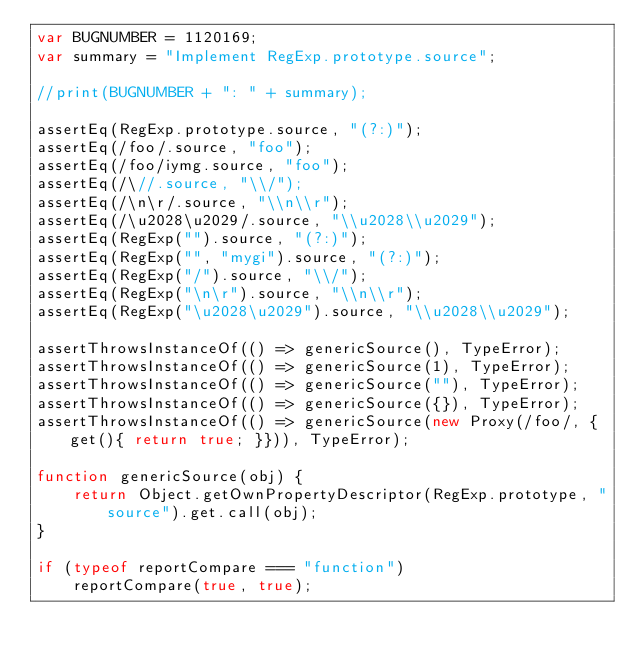<code> <loc_0><loc_0><loc_500><loc_500><_JavaScript_>var BUGNUMBER = 1120169;
var summary = "Implement RegExp.prototype.source";

//print(BUGNUMBER + ": " + summary);

assertEq(RegExp.prototype.source, "(?:)");
assertEq(/foo/.source, "foo");
assertEq(/foo/iymg.source, "foo");
assertEq(/\//.source, "\\/");
assertEq(/\n\r/.source, "\\n\\r");
assertEq(/\u2028\u2029/.source, "\\u2028\\u2029");
assertEq(RegExp("").source, "(?:)");
assertEq(RegExp("", "mygi").source, "(?:)");
assertEq(RegExp("/").source, "\\/");
assertEq(RegExp("\n\r").source, "\\n\\r");
assertEq(RegExp("\u2028\u2029").source, "\\u2028\\u2029");

assertThrowsInstanceOf(() => genericSource(), TypeError);
assertThrowsInstanceOf(() => genericSource(1), TypeError);
assertThrowsInstanceOf(() => genericSource(""), TypeError);
assertThrowsInstanceOf(() => genericSource({}), TypeError);
assertThrowsInstanceOf(() => genericSource(new Proxy(/foo/, {get(){ return true; }})), TypeError);

function genericSource(obj) {
    return Object.getOwnPropertyDescriptor(RegExp.prototype, "source").get.call(obj);
}

if (typeof reportCompare === "function")
    reportCompare(true, true);
</code> 